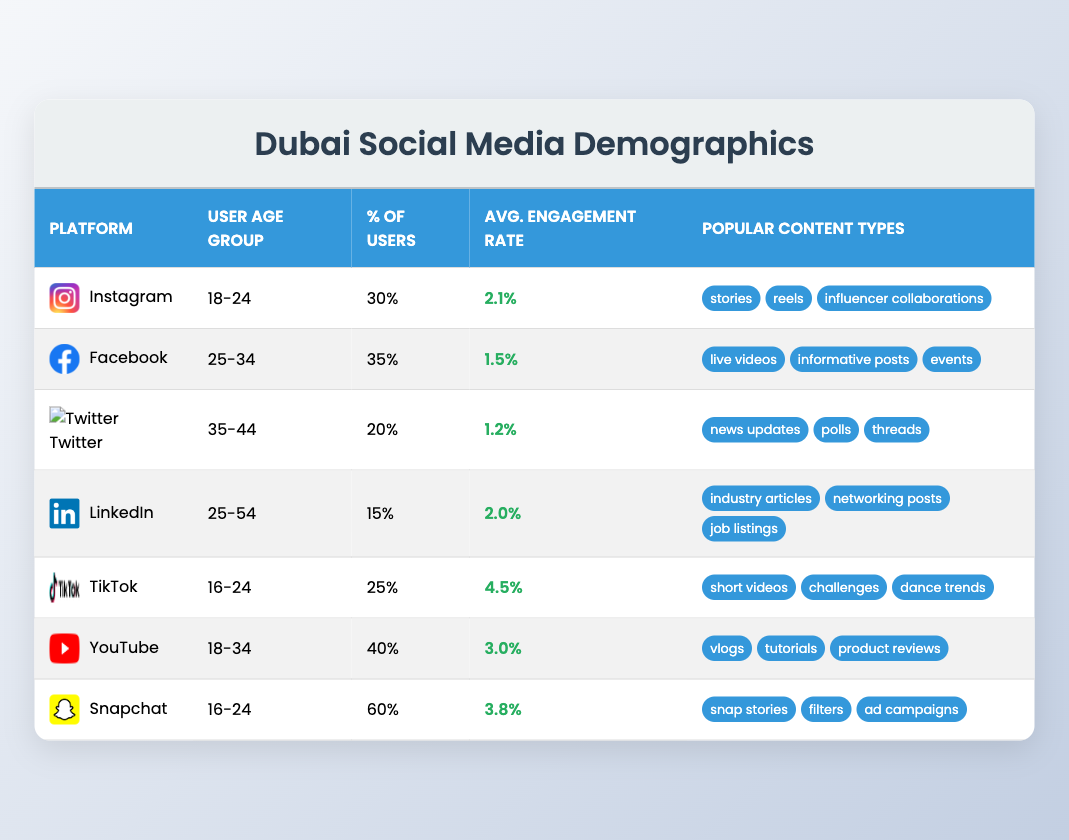What is the average engagement rate for the Instagram and TikTok platforms? The average engagement rates are 2.1% for Instagram and 4.5% for TikTok. Adding these two values gives 2.1 + 4.5 = 6.6. Dividing by 2 (the number of platforms) yields an average engagement rate of 6.6 / 2 = 3.3%.
Answer: 3.3% Which platform has the highest percentage of users? According to the table, Snapchat has the highest percentage of users at 60%.
Answer: 60% What age group uses Facebook? The table indicates that the user age group for Facebook is 25-34.
Answer: 25-34 Are short videos popular on LinkedIn? The popular content types for LinkedIn are industry articles, networking posts, and job listings. Short videos are not listed, hence they are not popular on LinkedIn.
Answer: No What percentage of users on YouTube are between the ages of 18-34? The table shows that 40% of YouTube users are in the age group of 18-34.
Answer: 40% How does the average engagement rate of Snapchat compare with that of Twitter? Snapchat has an average engagement rate of 3.8%, while Twitter has an average engagement rate of 1.2%. The difference is calculated as 3.8 - 1.2 = 2.6%. Thus, Snapchat has a higher engagement rate compared to Twitter.
Answer: Higher by 2.6% What type of content is not popular on TikTok but is popular on other platforms, say LinkedIn? TikTok is known for short videos, challenges, and dance trends, none of which are popular on LinkedIn, which focuses on industry articles, networking posts, and job listings. Hence, short videos are not popular on LinkedIn.
Answer: Short videos If we combine the user percentages from Instagram and TikTok, what is the total percentage of users? Instagram has 30% of users and TikTok has 25%. Adding these percentages gives 30 + 25 = 55%. Therefore, the total percentage of users from both platforms is 55%.
Answer: 55% Which platform has a higher engagement rate, YouTube or Facebook? YouTube has an engagement rate of 3.0% while Facebook has an engagement rate of 1.5%. Since 3.0% is greater than 1.5%, YouTube has a higher engagement rate.
Answer: YouTube What is the most popular content type for Snapchat? According to the table, the most popular content types for Snapchat include snap stories, filters, and ad campaigns.
Answer: Snap stories Is influencer collaboration a popular content type on any platform? The table shows that influencer collaborations are noted as popular on Instagram.
Answer: Yes 